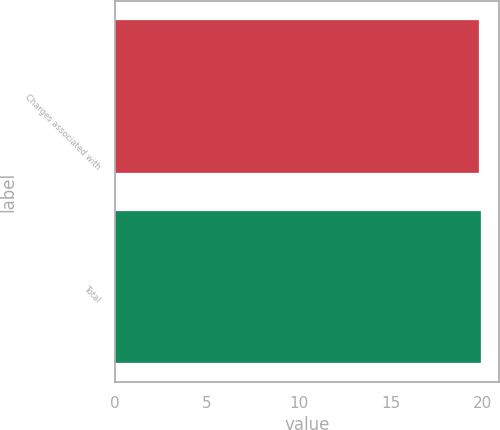Convert chart to OTSL. <chart><loc_0><loc_0><loc_500><loc_500><bar_chart><fcel>Charges associated with<fcel>Total<nl><fcel>19.8<fcel>19.9<nl></chart> 